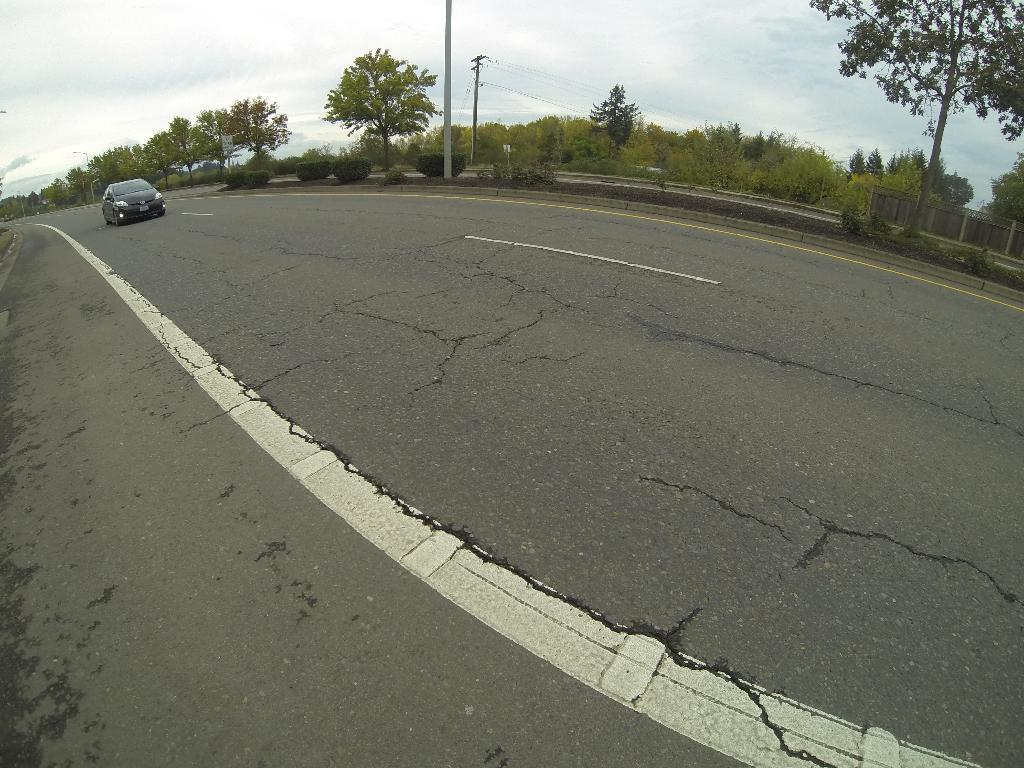What is the main feature of the image? There is a road in the image. Can you describe the condition of the road? The road has cracks. What type of vehicle is on the road? There is a black car on the road. What can be seen in the background of the image? There are trees, poles, a railing, and the sky visible in the background of the image. What is the annual income of the apple tree in the image? There is no apple tree present in the image, and therefore no income can be associated with it. 